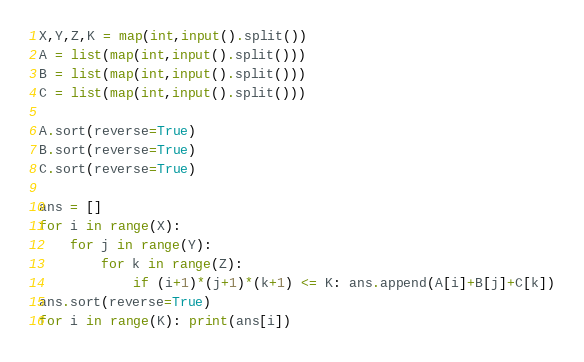<code> <loc_0><loc_0><loc_500><loc_500><_Python_>X,Y,Z,K = map(int,input().split())
A = list(map(int,input().split()))
B = list(map(int,input().split()))
C = list(map(int,input().split()))

A.sort(reverse=True)
B.sort(reverse=True)
C.sort(reverse=True)

ans = []
for i in range(X):
    for j in range(Y):
        for k in range(Z):
            if (i+1)*(j+1)*(k+1) <= K: ans.append(A[i]+B[j]+C[k])
ans.sort(reverse=True)
for i in range(K): print(ans[i])</code> 